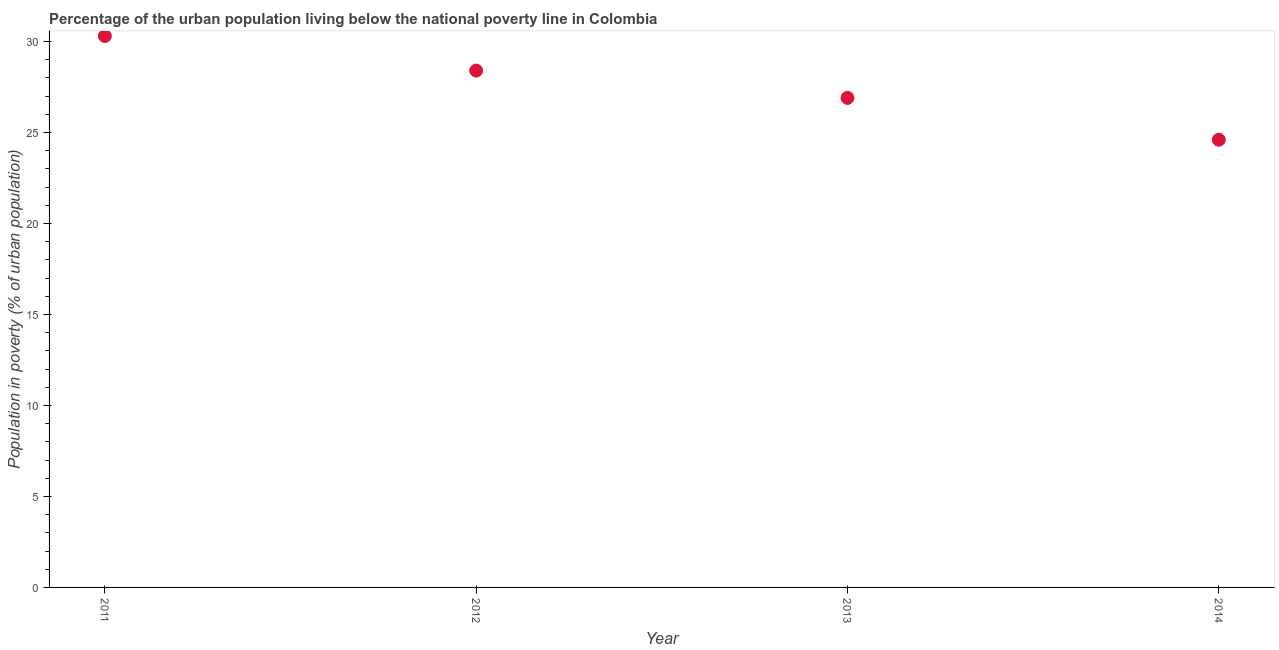What is the percentage of urban population living below poverty line in 2013?
Your answer should be very brief. 26.9. Across all years, what is the maximum percentage of urban population living below poverty line?
Your answer should be very brief. 30.3. Across all years, what is the minimum percentage of urban population living below poverty line?
Your response must be concise. 24.6. What is the sum of the percentage of urban population living below poverty line?
Offer a terse response. 110.2. What is the difference between the percentage of urban population living below poverty line in 2011 and 2012?
Ensure brevity in your answer.  1.9. What is the average percentage of urban population living below poverty line per year?
Your answer should be very brief. 27.55. What is the median percentage of urban population living below poverty line?
Provide a succinct answer. 27.65. In how many years, is the percentage of urban population living below poverty line greater than 21 %?
Your response must be concise. 4. What is the ratio of the percentage of urban population living below poverty line in 2012 to that in 2013?
Ensure brevity in your answer.  1.06. Is the percentage of urban population living below poverty line in 2011 less than that in 2012?
Provide a succinct answer. No. What is the difference between the highest and the second highest percentage of urban population living below poverty line?
Provide a succinct answer. 1.9. Is the sum of the percentage of urban population living below poverty line in 2013 and 2014 greater than the maximum percentage of urban population living below poverty line across all years?
Ensure brevity in your answer.  Yes. What is the difference between the highest and the lowest percentage of urban population living below poverty line?
Offer a terse response. 5.7. In how many years, is the percentage of urban population living below poverty line greater than the average percentage of urban population living below poverty line taken over all years?
Keep it short and to the point. 2. Does the percentage of urban population living below poverty line monotonically increase over the years?
Provide a short and direct response. No. How many years are there in the graph?
Your answer should be compact. 4. What is the difference between two consecutive major ticks on the Y-axis?
Your response must be concise. 5. What is the title of the graph?
Provide a succinct answer. Percentage of the urban population living below the national poverty line in Colombia. What is the label or title of the Y-axis?
Give a very brief answer. Population in poverty (% of urban population). What is the Population in poverty (% of urban population) in 2011?
Your answer should be compact. 30.3. What is the Population in poverty (% of urban population) in 2012?
Your answer should be very brief. 28.4. What is the Population in poverty (% of urban population) in 2013?
Offer a terse response. 26.9. What is the Population in poverty (% of urban population) in 2014?
Your answer should be compact. 24.6. What is the difference between the Population in poverty (% of urban population) in 2011 and 2013?
Keep it short and to the point. 3.4. What is the difference between the Population in poverty (% of urban population) in 2011 and 2014?
Make the answer very short. 5.7. What is the difference between the Population in poverty (% of urban population) in 2013 and 2014?
Your answer should be very brief. 2.3. What is the ratio of the Population in poverty (% of urban population) in 2011 to that in 2012?
Your response must be concise. 1.07. What is the ratio of the Population in poverty (% of urban population) in 2011 to that in 2013?
Offer a very short reply. 1.13. What is the ratio of the Population in poverty (% of urban population) in 2011 to that in 2014?
Offer a very short reply. 1.23. What is the ratio of the Population in poverty (% of urban population) in 2012 to that in 2013?
Make the answer very short. 1.06. What is the ratio of the Population in poverty (% of urban population) in 2012 to that in 2014?
Your answer should be compact. 1.15. What is the ratio of the Population in poverty (% of urban population) in 2013 to that in 2014?
Your answer should be very brief. 1.09. 